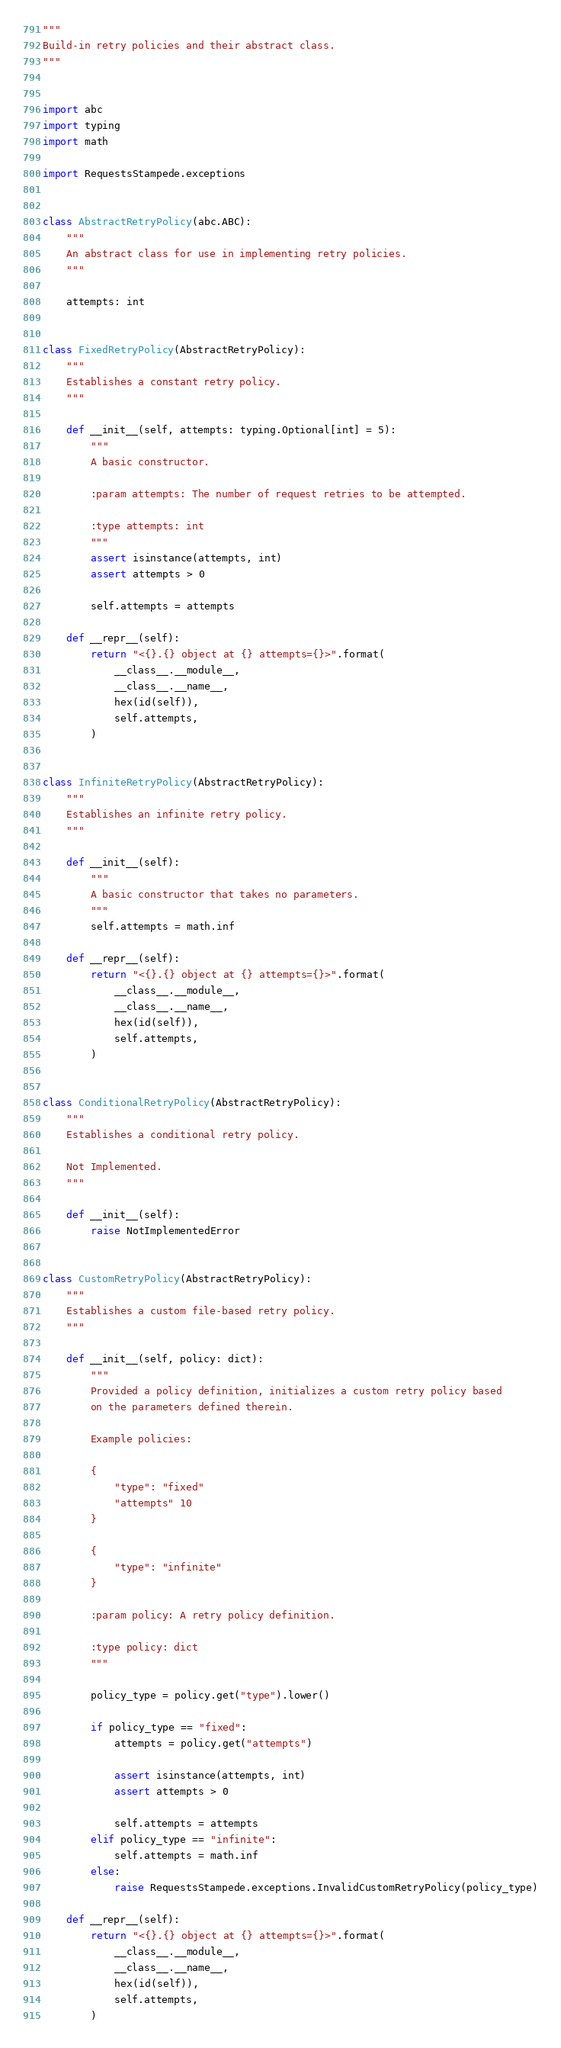Convert code to text. <code><loc_0><loc_0><loc_500><loc_500><_Python_>"""
Build-in retry policies and their abstract class.
"""


import abc
import typing
import math

import RequestsStampede.exceptions


class AbstractRetryPolicy(abc.ABC):
    """
    An abstract class for use in implementing retry policies.
    """

    attempts: int


class FixedRetryPolicy(AbstractRetryPolicy):
    """
    Establishes a constant retry policy.
    """

    def __init__(self, attempts: typing.Optional[int] = 5):
        """
        A basic constructor.

        :param attempts: The number of request retries to be attempted.

        :type attempts: int
        """
        assert isinstance(attempts, int)
        assert attempts > 0

        self.attempts = attempts

    def __repr__(self):
        return "<{}.{} object at {} attempts={}>".format(
            __class__.__module__,
            __class__.__name__,
            hex(id(self)),
            self.attempts,
        )


class InfiniteRetryPolicy(AbstractRetryPolicy):
    """
    Establishes an infinite retry policy.
    """

    def __init__(self):
        """
        A basic constructor that takes no parameters.
        """
        self.attempts = math.inf

    def __repr__(self):
        return "<{}.{} object at {} attempts={}>".format(
            __class__.__module__,
            __class__.__name__,
            hex(id(self)),
            self.attempts,
        )


class ConditionalRetryPolicy(AbstractRetryPolicy):
    """
    Establishes a conditional retry policy.

    Not Implemented.
    """

    def __init__(self):
        raise NotImplementedError


class CustomRetryPolicy(AbstractRetryPolicy):
    """
    Establishes a custom file-based retry policy.
    """

    def __init__(self, policy: dict):
        """
        Provided a policy definition, initializes a custom retry policy based
        on the parameters defined therein.

        Example policies:

        {
            "type": "fixed"
            "attempts" 10
        }

        {
            "type": "infinite"
        }

        :param policy: A retry policy definition.

        :type policy: dict
        """

        policy_type = policy.get("type").lower()

        if policy_type == "fixed":
            attempts = policy.get("attempts")

            assert isinstance(attempts, int)
            assert attempts > 0

            self.attempts = attempts
        elif policy_type == "infinite":
            self.attempts = math.inf
        else:
            raise RequestsStampede.exceptions.InvalidCustomRetryPolicy(policy_type)

    def __repr__(self):
        return "<{}.{} object at {} attempts={}>".format(
            __class__.__module__,
            __class__.__name__,
            hex(id(self)),
            self.attempts,
        )
</code> 